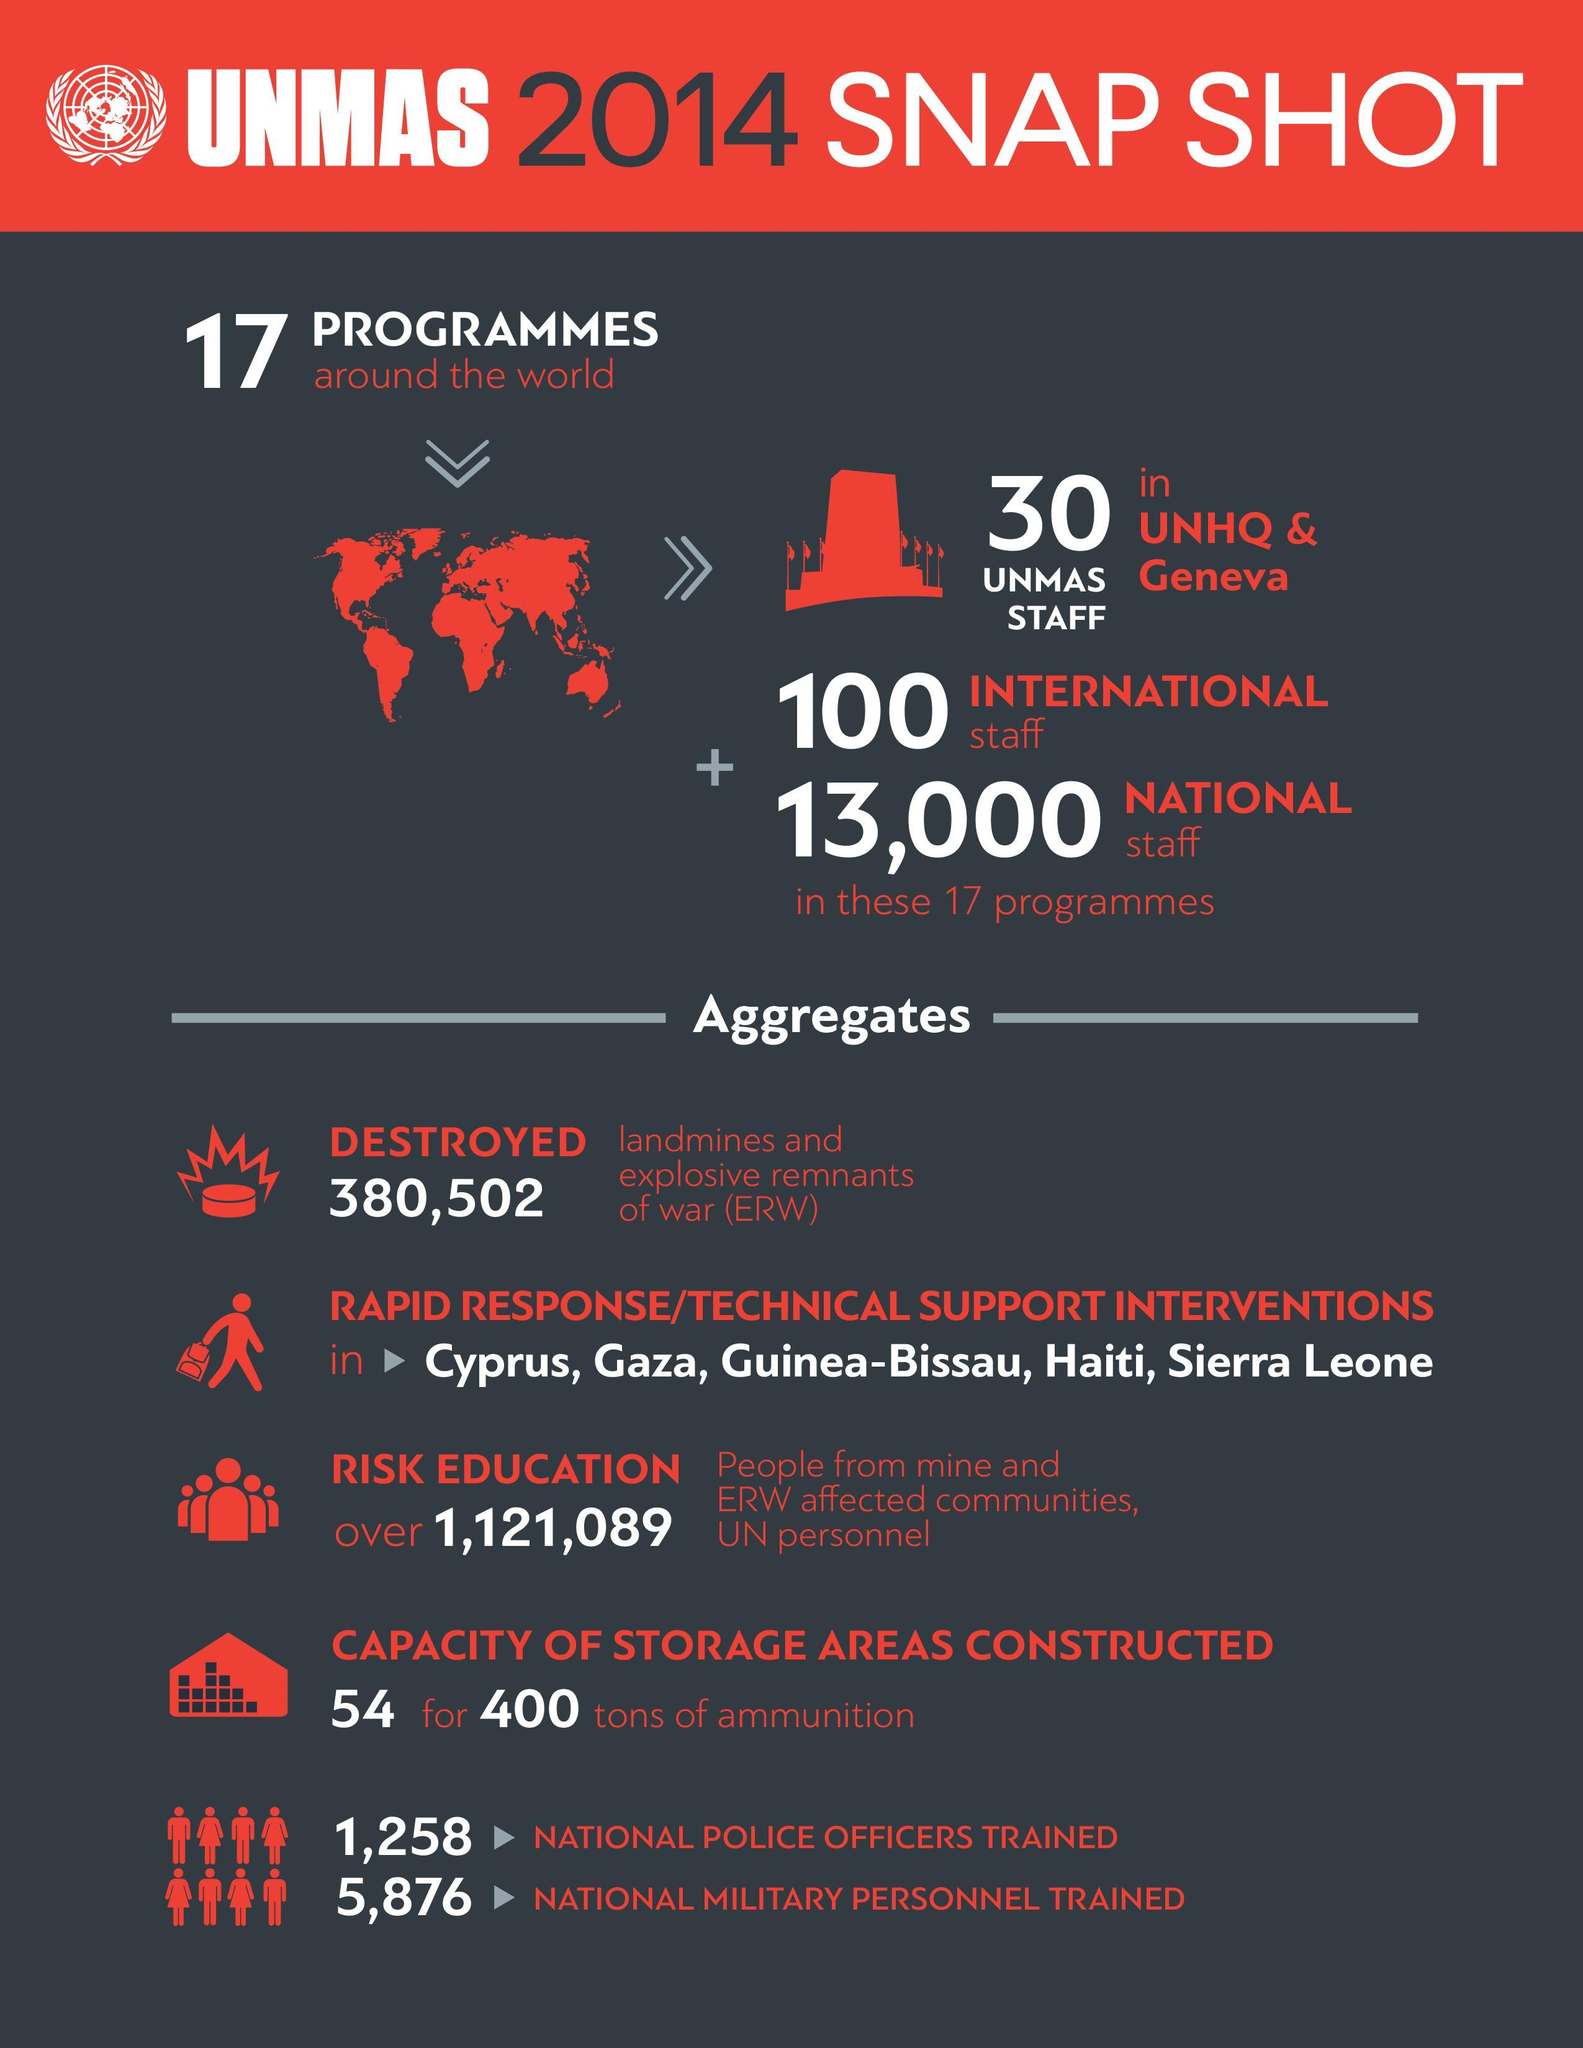What is the total number of National and International staff in the 17 programmes conducted by UN?
Answer the question with a short phrase. 13,100 What is total number of police officers and military personnel trained? 7,134 How many regions were the technical support or rapid response interventions under taken? 5 How many rapid response interventions were undertaken by UNMAS in 2014? 5 